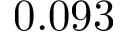Convert formula to latex. <formula><loc_0><loc_0><loc_500><loc_500>0 . 0 9 3</formula> 